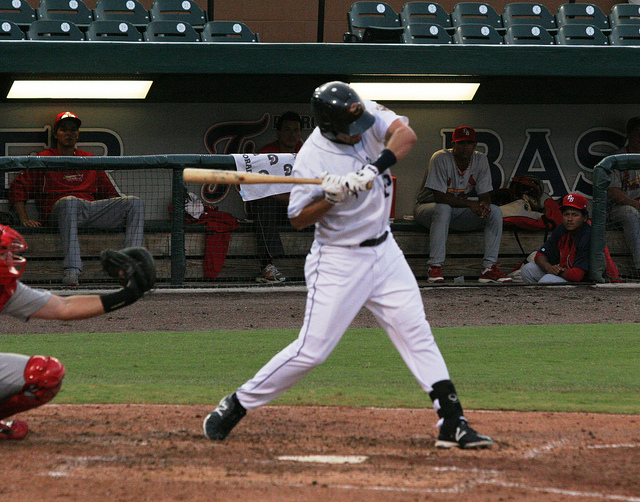<image>What is the logo on his wristband? I don't know what is the logo on his wristband. It can be Nike, Easton, Wilson or none. What is the logo on his wristband? I don't know what is the logo on his wristband. It can be 'nike', 'easton', 'black', 'wilson', 'white', or none. 